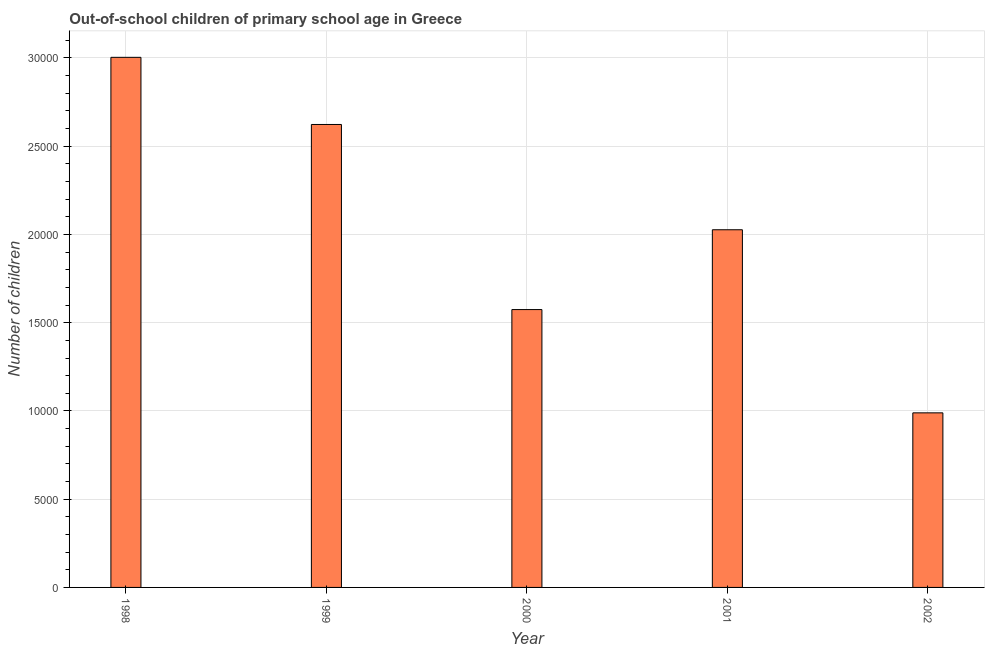Does the graph contain grids?
Make the answer very short. Yes. What is the title of the graph?
Give a very brief answer. Out-of-school children of primary school age in Greece. What is the label or title of the X-axis?
Your answer should be compact. Year. What is the label or title of the Y-axis?
Keep it short and to the point. Number of children. What is the number of out-of-school children in 2000?
Provide a short and direct response. 1.57e+04. Across all years, what is the maximum number of out-of-school children?
Offer a very short reply. 3.00e+04. Across all years, what is the minimum number of out-of-school children?
Offer a very short reply. 9892. In which year was the number of out-of-school children minimum?
Provide a succinct answer. 2002. What is the sum of the number of out-of-school children?
Offer a very short reply. 1.02e+05. What is the difference between the number of out-of-school children in 1998 and 2001?
Ensure brevity in your answer.  9770. What is the average number of out-of-school children per year?
Ensure brevity in your answer.  2.04e+04. What is the median number of out-of-school children?
Offer a very short reply. 2.03e+04. Do a majority of the years between 1998 and 2001 (inclusive) have number of out-of-school children greater than 30000 ?
Offer a very short reply. No. What is the ratio of the number of out-of-school children in 1998 to that in 2002?
Offer a terse response. 3.04. What is the difference between the highest and the second highest number of out-of-school children?
Your answer should be very brief. 3805. What is the difference between the highest and the lowest number of out-of-school children?
Ensure brevity in your answer.  2.01e+04. In how many years, is the number of out-of-school children greater than the average number of out-of-school children taken over all years?
Your answer should be very brief. 2. How many bars are there?
Give a very brief answer. 5. What is the difference between two consecutive major ticks on the Y-axis?
Your answer should be compact. 5000. Are the values on the major ticks of Y-axis written in scientific E-notation?
Offer a very short reply. No. What is the Number of children in 1998?
Offer a terse response. 3.00e+04. What is the Number of children in 1999?
Make the answer very short. 2.62e+04. What is the Number of children of 2000?
Provide a succinct answer. 1.57e+04. What is the Number of children of 2001?
Keep it short and to the point. 2.03e+04. What is the Number of children of 2002?
Your answer should be very brief. 9892. What is the difference between the Number of children in 1998 and 1999?
Make the answer very short. 3805. What is the difference between the Number of children in 1998 and 2000?
Your answer should be very brief. 1.43e+04. What is the difference between the Number of children in 1998 and 2001?
Offer a very short reply. 9770. What is the difference between the Number of children in 1998 and 2002?
Provide a succinct answer. 2.01e+04. What is the difference between the Number of children in 1999 and 2000?
Ensure brevity in your answer.  1.05e+04. What is the difference between the Number of children in 1999 and 2001?
Ensure brevity in your answer.  5965. What is the difference between the Number of children in 1999 and 2002?
Ensure brevity in your answer.  1.63e+04. What is the difference between the Number of children in 2000 and 2001?
Ensure brevity in your answer.  -4523. What is the difference between the Number of children in 2000 and 2002?
Offer a terse response. 5852. What is the difference between the Number of children in 2001 and 2002?
Offer a very short reply. 1.04e+04. What is the ratio of the Number of children in 1998 to that in 1999?
Give a very brief answer. 1.15. What is the ratio of the Number of children in 1998 to that in 2000?
Your answer should be very brief. 1.91. What is the ratio of the Number of children in 1998 to that in 2001?
Your answer should be compact. 1.48. What is the ratio of the Number of children in 1998 to that in 2002?
Provide a short and direct response. 3.04. What is the ratio of the Number of children in 1999 to that in 2000?
Your response must be concise. 1.67. What is the ratio of the Number of children in 1999 to that in 2001?
Ensure brevity in your answer.  1.29. What is the ratio of the Number of children in 1999 to that in 2002?
Offer a terse response. 2.65. What is the ratio of the Number of children in 2000 to that in 2001?
Your response must be concise. 0.78. What is the ratio of the Number of children in 2000 to that in 2002?
Your answer should be very brief. 1.59. What is the ratio of the Number of children in 2001 to that in 2002?
Your response must be concise. 2.05. 